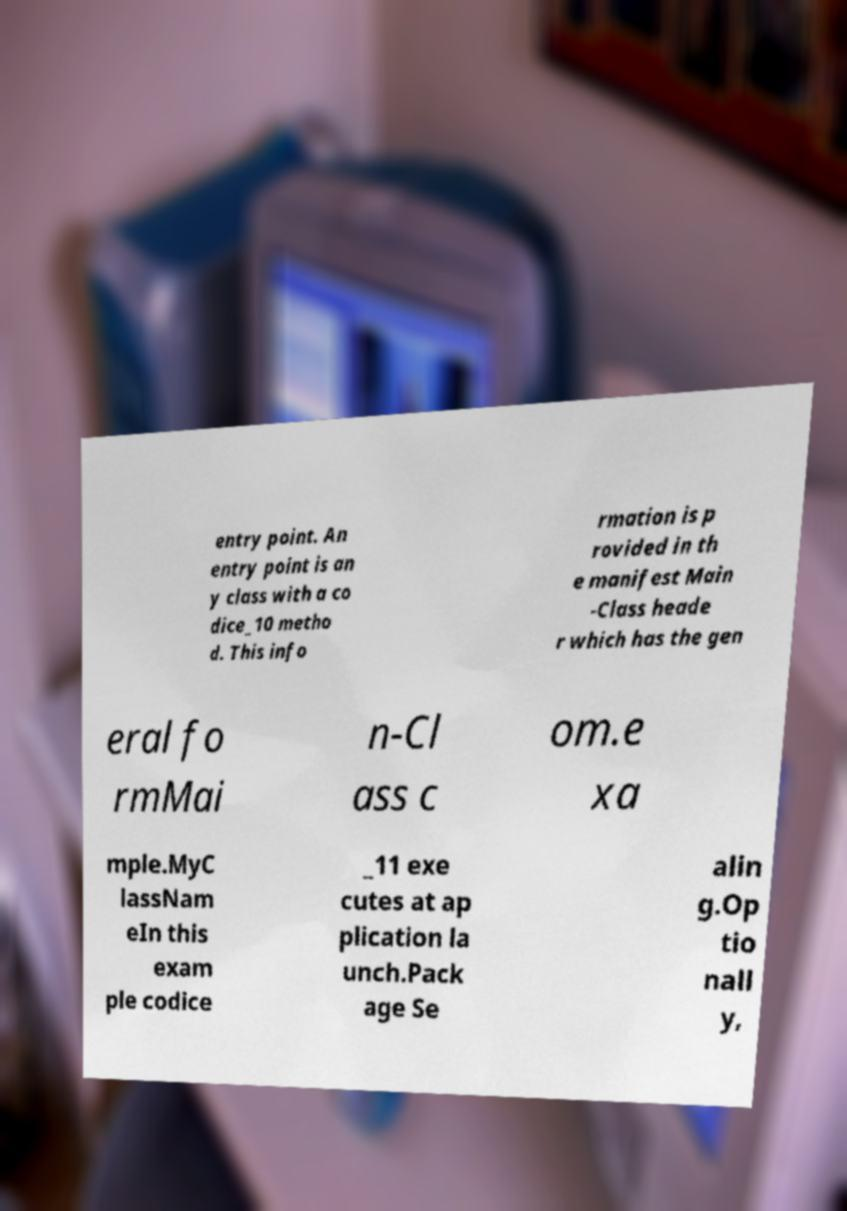Could you extract and type out the text from this image? entry point. An entry point is an y class with a co dice_10 metho d. This info rmation is p rovided in th e manifest Main -Class heade r which has the gen eral fo rmMai n-Cl ass c om.e xa mple.MyC lassNam eIn this exam ple codice _11 exe cutes at ap plication la unch.Pack age Se alin g.Op tio nall y, 